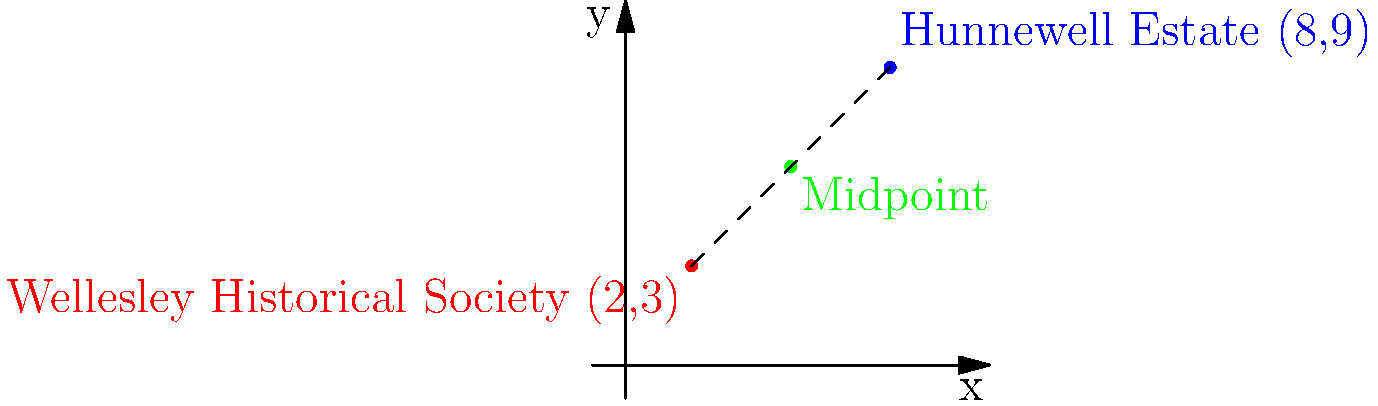As part of your historical research on Wellesley's landmarks, you're mapping significant locations. The Wellesley Historical Society is located at coordinates (2,3) on your grid, while the historic Hunnewell Estate is at (8,9). To plan a walking tour that includes both sites, you need to find a suitable midpoint for a rest area. What are the coordinates of the midpoint between these two landmarks? To find the midpoint between two points, we use the midpoint formula:

$$ \text{Midpoint} = \left(\frac{x_1 + x_2}{2}, \frac{y_1 + y_2}{2}\right) $$

Where $(x_1, y_1)$ are the coordinates of the first point and $(x_2, y_2)$ are the coordinates of the second point.

1. Identify the coordinates:
   - Wellesley Historical Society: $(x_1, y_1) = (2, 3)$
   - Hunnewell Estate: $(x_2, y_2) = (8, 9)$

2. Apply the midpoint formula:
   $$ x = \frac{x_1 + x_2}{2} = \frac{2 + 8}{2} = \frac{10}{2} = 5 $$
   $$ y = \frac{y_1 + y_2}{2} = \frac{3 + 9}{2} = \frac{12}{2} = 6 $$

3. Therefore, the midpoint coordinates are (5, 6).

This point represents the ideal location for a rest area on your historical walking tour, being equidistant from both the Wellesley Historical Society and the Hunnewell Estate.
Answer: (5, 6) 